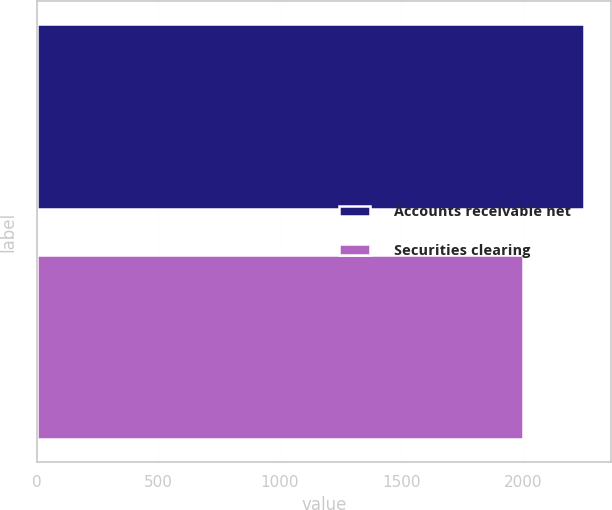<chart> <loc_0><loc_0><loc_500><loc_500><bar_chart><fcel>Accounts receivable net<fcel>Securities clearing<nl><fcel>2251<fcel>2000<nl></chart> 